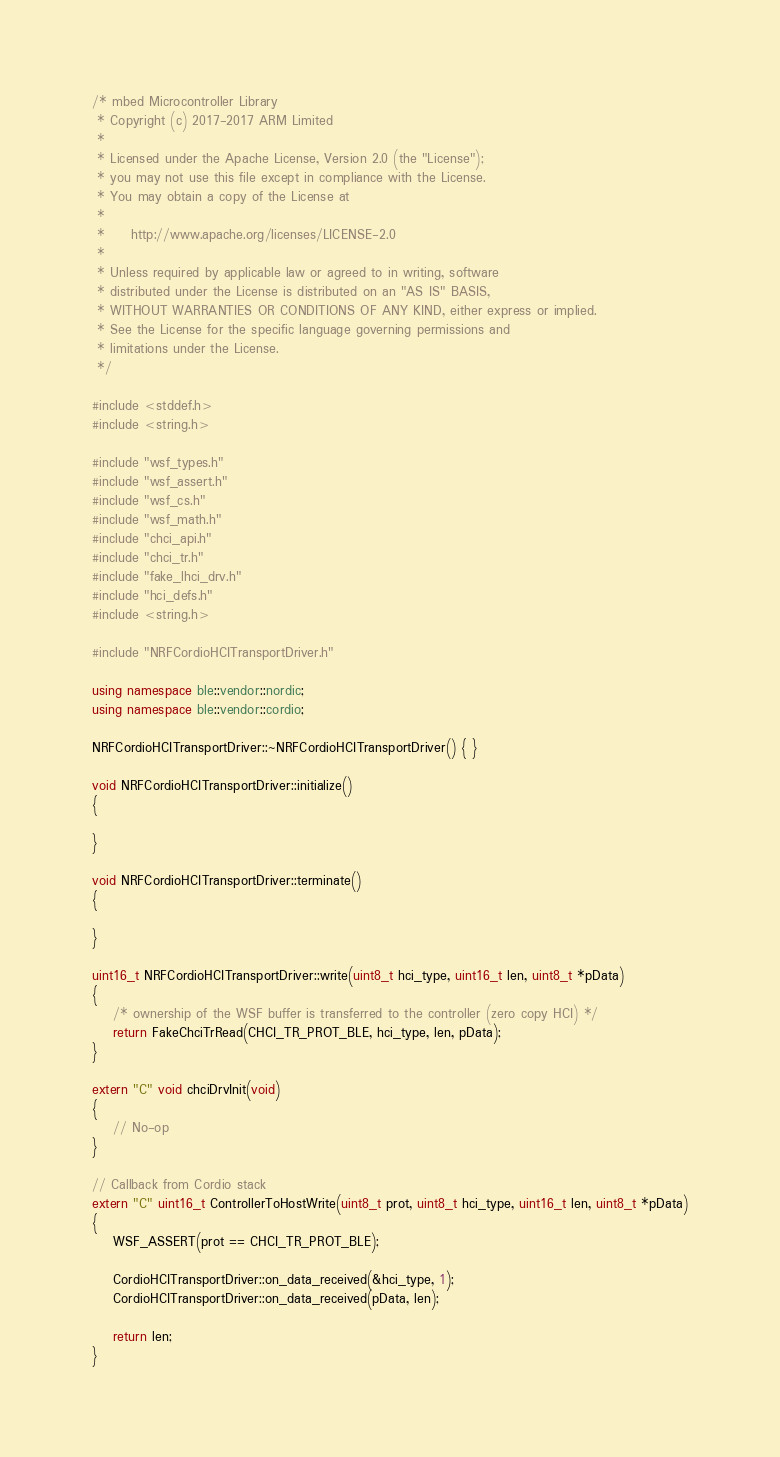<code> <loc_0><loc_0><loc_500><loc_500><_C++_>/* mbed Microcontroller Library
 * Copyright (c) 2017-2017 ARM Limited
 *
 * Licensed under the Apache License, Version 2.0 (the "License");
 * you may not use this file except in compliance with the License.
 * You may obtain a copy of the License at
 *
 *     http://www.apache.org/licenses/LICENSE-2.0
 *
 * Unless required by applicable law or agreed to in writing, software
 * distributed under the License is distributed on an "AS IS" BASIS,
 * WITHOUT WARRANTIES OR CONDITIONS OF ANY KIND, either express or implied.
 * See the License for the specific language governing permissions and
 * limitations under the License.
 */

#include <stddef.h>
#include <string.h>

#include "wsf_types.h"
#include "wsf_assert.h"
#include "wsf_cs.h"
#include "wsf_math.h"
#include "chci_api.h"
#include "chci_tr.h"
#include "fake_lhci_drv.h"
#include "hci_defs.h"
#include <string.h>

#include "NRFCordioHCITransportDriver.h"

using namespace ble::vendor::nordic;
using namespace ble::vendor::cordio;

NRFCordioHCITransportDriver::~NRFCordioHCITransportDriver() { }

void NRFCordioHCITransportDriver::initialize()
{

}

void NRFCordioHCITransportDriver::terminate()
{

}

uint16_t NRFCordioHCITransportDriver::write(uint8_t hci_type, uint16_t len, uint8_t *pData)
{
    /* ownership of the WSF buffer is transferred to the controller (zero copy HCI) */
    return FakeChciTrRead(CHCI_TR_PROT_BLE, hci_type, len, pData);
}

extern "C" void chciDrvInit(void)
{
    // No-op
}

// Callback from Cordio stack
extern "C" uint16_t ControllerToHostWrite(uint8_t prot, uint8_t hci_type, uint16_t len, uint8_t *pData)
{
    WSF_ASSERT(prot == CHCI_TR_PROT_BLE);

    CordioHCITransportDriver::on_data_received(&hci_type, 1);
    CordioHCITransportDriver::on_data_received(pData, len);

    return len;
}
</code> 